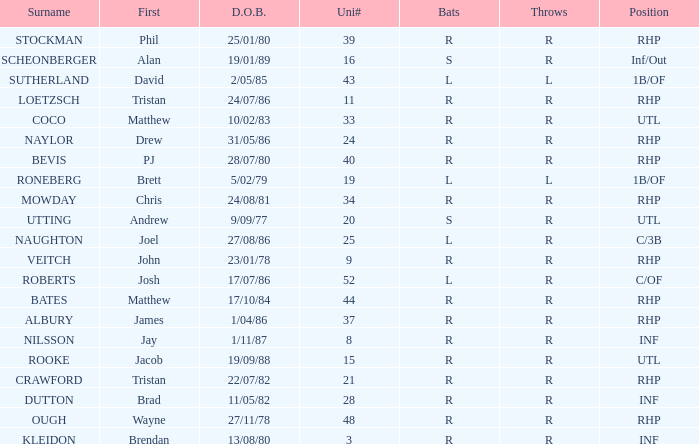How many Uni numbers have Bats of s, and a Position of utl? 1.0. 